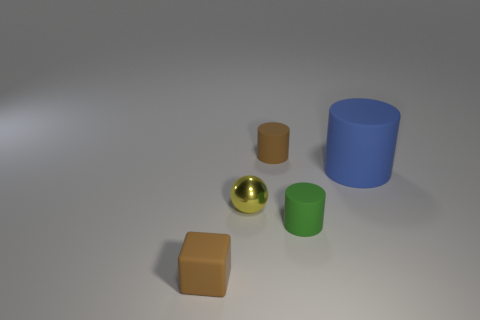Is the number of big blue rubber objects that are in front of the big rubber thing the same as the number of big blue rubber things that are behind the small brown block?
Provide a short and direct response. No. What shape is the matte object that is to the right of the matte cube and on the left side of the tiny green thing?
Offer a terse response. Cylinder. There is a cube; how many tiny things are on the right side of it?
Your response must be concise. 3. How many other things are there of the same shape as the blue object?
Offer a terse response. 2. Are there fewer tiny blocks than small matte things?
Give a very brief answer. Yes. There is a rubber cylinder that is both behind the small yellow thing and left of the large rubber cylinder; how big is it?
Offer a terse response. Small. What size is the thing in front of the tiny cylinder to the right of the tiny brown matte object that is on the right side of the yellow metallic object?
Your response must be concise. Small. What size is the blue matte thing?
Provide a short and direct response. Large. Are there any other things that are made of the same material as the ball?
Offer a terse response. No. There is a brown thing on the left side of the small brown matte thing behind the cube; is there a blue cylinder behind it?
Your answer should be very brief. Yes. 